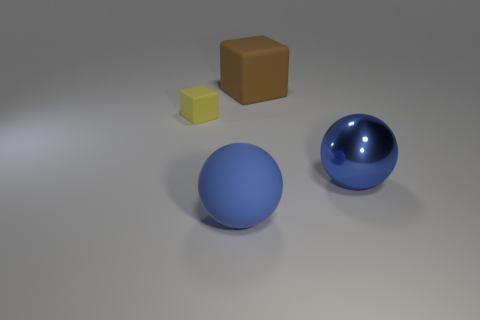What is the color of the block that is the same size as the matte sphere?
Provide a succinct answer. Brown. What number of other things are there of the same shape as the tiny thing?
Provide a succinct answer. 1. There is a blue ball that is behind the rubber sphere; how big is it?
Offer a terse response. Large. What number of big blue objects are on the right side of the blue ball that is behind the blue rubber sphere?
Offer a very short reply. 0. What number of other objects are there of the same size as the yellow cube?
Provide a short and direct response. 0. Does the metallic ball have the same color as the large matte sphere?
Make the answer very short. Yes. There is a big thing that is to the left of the brown rubber block; does it have the same shape as the small object?
Your answer should be compact. No. What number of large things are both in front of the brown matte cube and behind the blue rubber thing?
Your answer should be very brief. 1. What is the tiny cube made of?
Provide a short and direct response. Rubber. Is there any other thing that has the same color as the large metallic thing?
Provide a short and direct response. Yes. 